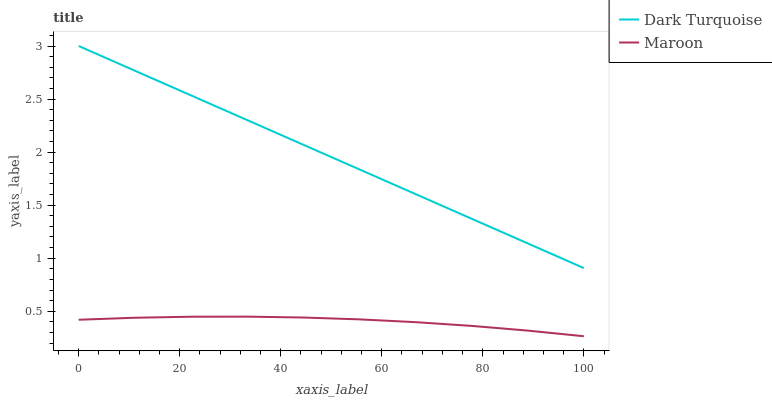Does Maroon have the minimum area under the curve?
Answer yes or no. Yes. Does Dark Turquoise have the maximum area under the curve?
Answer yes or no. Yes. Does Maroon have the maximum area under the curve?
Answer yes or no. No. Is Dark Turquoise the smoothest?
Answer yes or no. Yes. Is Maroon the roughest?
Answer yes or no. Yes. Is Maroon the smoothest?
Answer yes or no. No. Does Maroon have the lowest value?
Answer yes or no. Yes. Does Dark Turquoise have the highest value?
Answer yes or no. Yes. Does Maroon have the highest value?
Answer yes or no. No. Is Maroon less than Dark Turquoise?
Answer yes or no. Yes. Is Dark Turquoise greater than Maroon?
Answer yes or no. Yes. Does Maroon intersect Dark Turquoise?
Answer yes or no. No. 